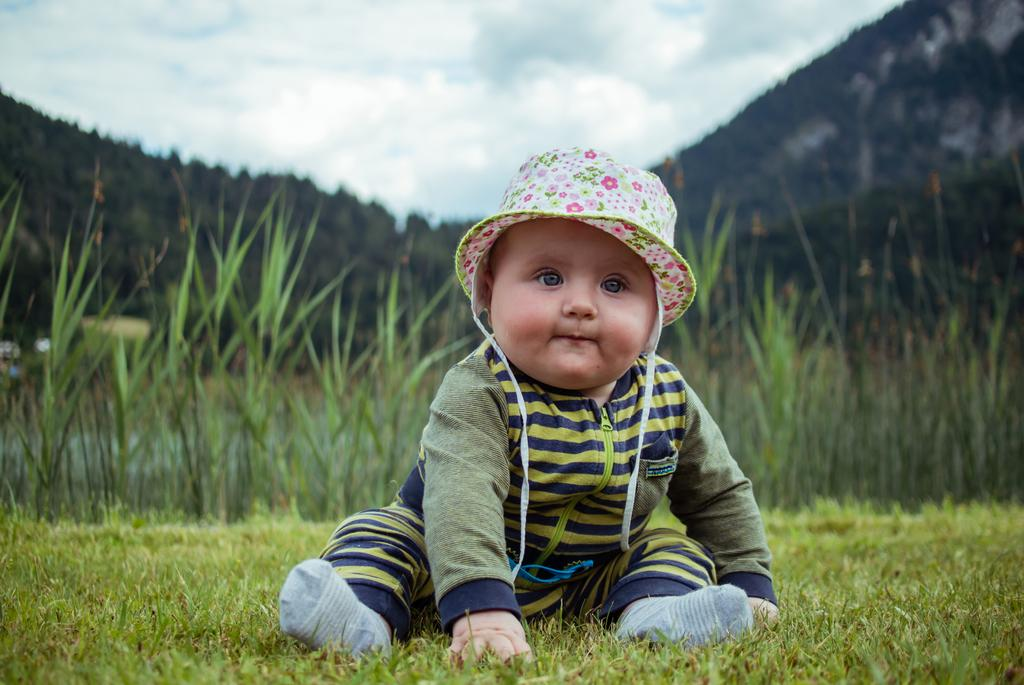What is the main subject of the picture? The main subject of the picture is a baby. What is the baby wearing on their head? The baby is wearing a cap. What is the baby wearing on their feet? The baby is wearing socks. Where is the baby sitting? The baby is sitting on the grass. What can be seen in the background of the image? There are plants, mountains, and the sky visible in the background of the image. What is the condition of the sky in the image? The sky is visible, and clouds are present in the image. How many sisters does the baby have in the image? There is no mention of sisters in the image, so it cannot be determined. What type of gold object is visible in the image? There is no gold object present in the image. 